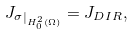<formula> <loc_0><loc_0><loc_500><loc_500>{ J _ { \sigma } } _ { | _ { H ^ { 2 } _ { 0 } ( \Omega ) } } = J _ { D I R } ,</formula> 